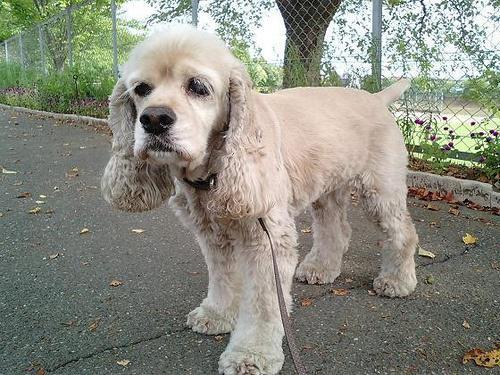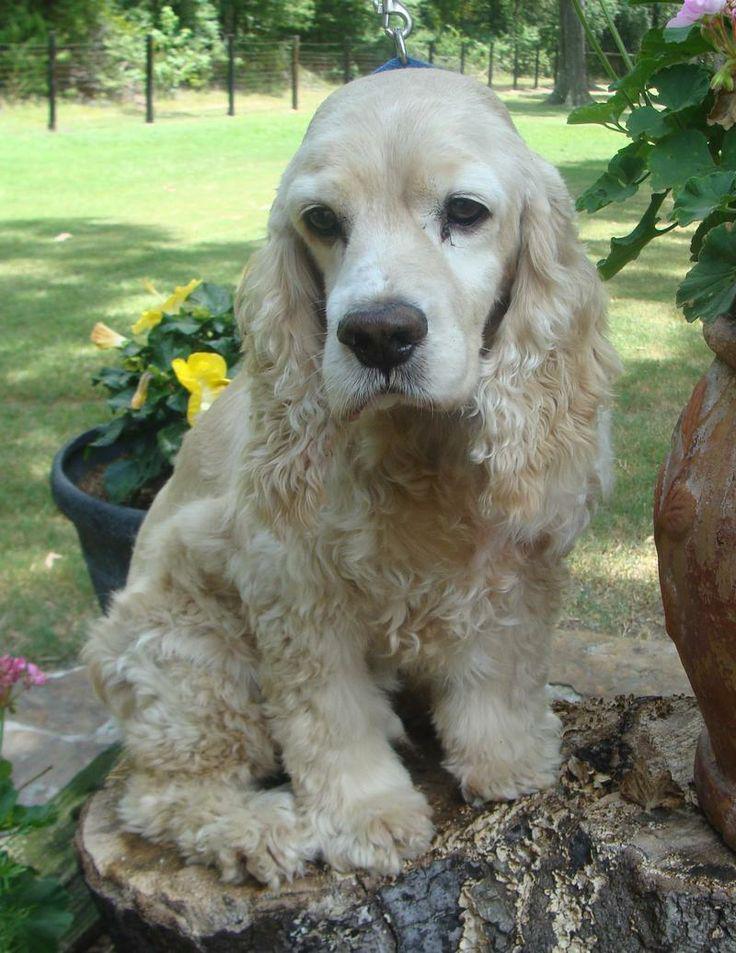The first image is the image on the left, the second image is the image on the right. For the images shown, is this caption "There is a fence in the background of one of the images." true? Answer yes or no. Yes. 